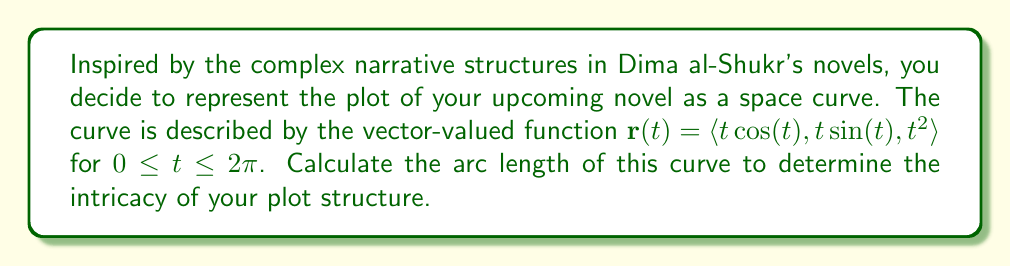Solve this math problem. To find the arc length of a space curve represented by a vector-valued function $\mathbf{r}(t)$, we use the formula:

$$L = \int_a^b |\mathbf{r}'(t)| dt$$

where $\mathbf{r}'(t)$ is the derivative of $\mathbf{r}(t)$, and $|\mathbf{r}'(t)|$ is its magnitude.

Step 1: Find $\mathbf{r}'(t)$
$$\mathbf{r}'(t) = \langle \cos(t) - t\sin(t), \sin(t) + t\cos(t), 2t \rangle$$

Step 2: Calculate $|\mathbf{r}'(t)|$
$$|\mathbf{r}'(t)| = \sqrt{(\cos(t) - t\sin(t))^2 + (\sin(t) + t\cos(t))^2 + (2t)^2}$$

Step 3: Simplify $|\mathbf{r}'(t)|$
$$\begin{aligned}
|\mathbf{r}'(t)| &= \sqrt{\cos^2(t) - 2t\cos(t)\sin(t) + t^2\sin^2(t) + \sin^2(t) + 2t\sin(t)\cos(t) + t^2\cos^2(t) + 4t^2} \\
&= \sqrt{\cos^2(t) + \sin^2(t) + t^2(\sin^2(t) + \cos^2(t)) + 4t^2} \\
&= \sqrt{1 + t^2 + 4t^2} \\
&= \sqrt{1 + 5t^2}
\end{aligned}$$

Step 4: Set up the integral
$$L = \int_0^{2\pi} \sqrt{1 + 5t^2} dt$$

Step 5: This integral cannot be evaluated using elementary functions. We need to use numerical integration methods or special functions. Using a computer algebra system or numerical integration tool, we can approximate the result.
Answer: The arc length of the space curve representing the plot structure is approximately $22.6$ units. 